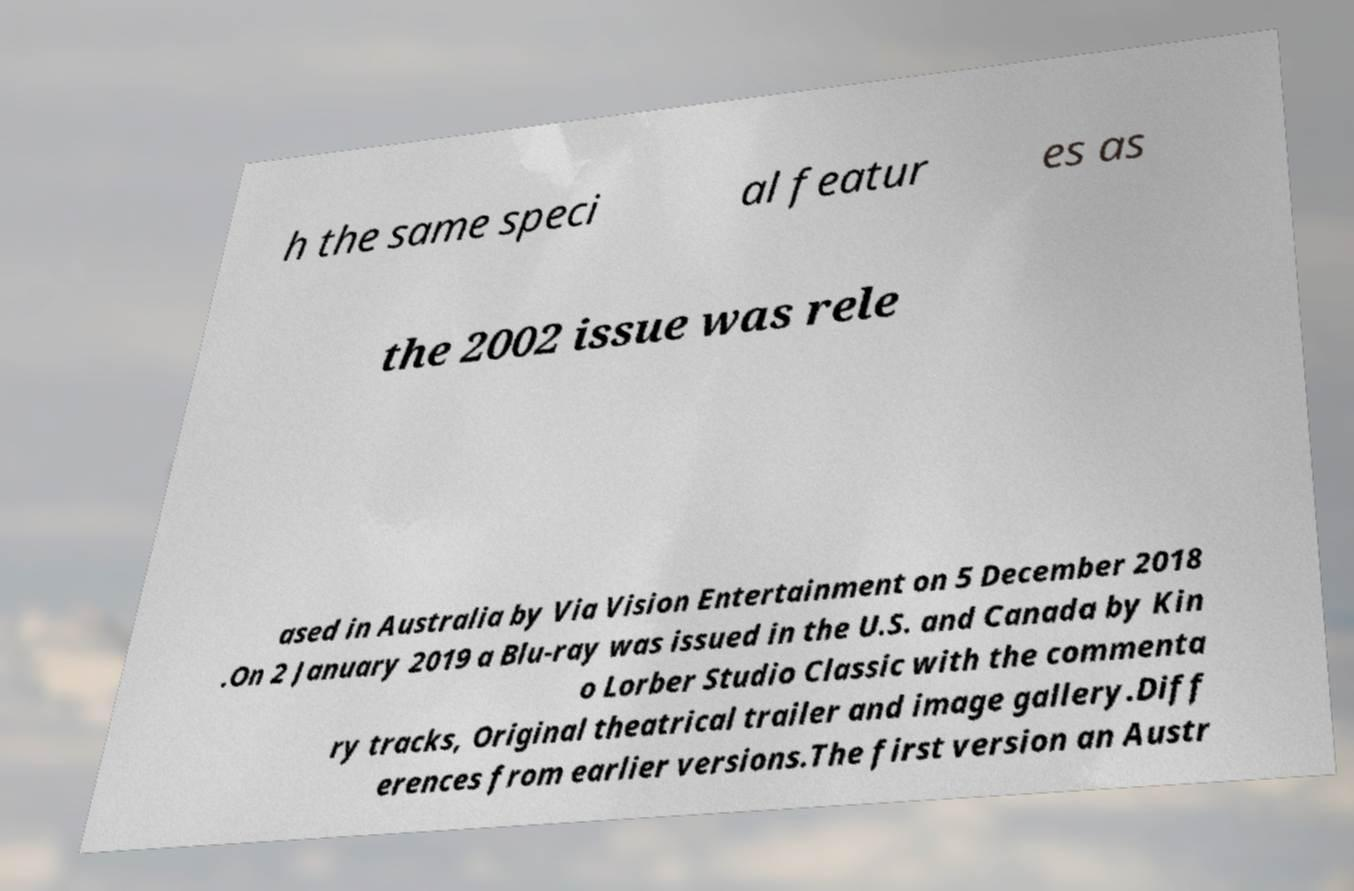Please read and relay the text visible in this image. What does it say? h the same speci al featur es as the 2002 issue was rele ased in Australia by Via Vision Entertainment on 5 December 2018 .On 2 January 2019 a Blu-ray was issued in the U.S. and Canada by Kin o Lorber Studio Classic with the commenta ry tracks, Original theatrical trailer and image gallery.Diff erences from earlier versions.The first version an Austr 